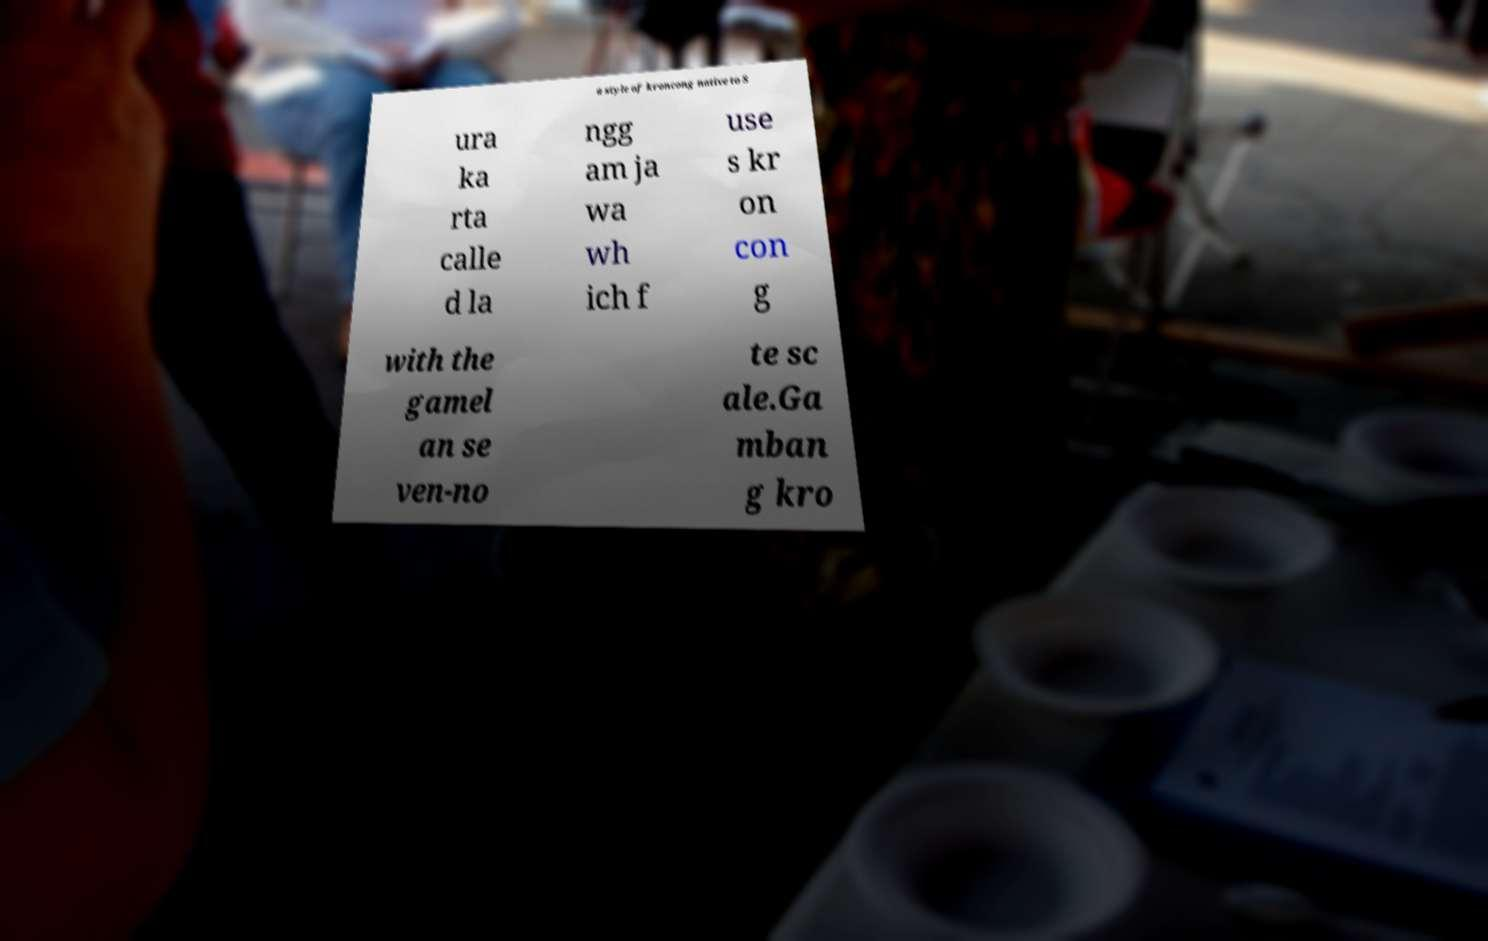What messages or text are displayed in this image? I need them in a readable, typed format. a style of kroncong native to S ura ka rta calle d la ngg am ja wa wh ich f use s kr on con g with the gamel an se ven-no te sc ale.Ga mban g kro 